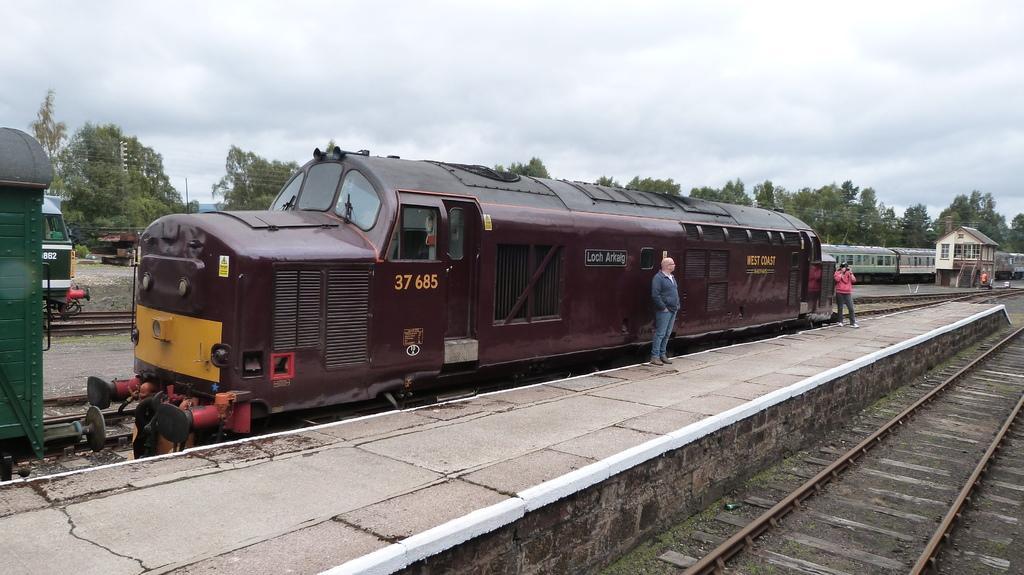Please provide a concise description of this image. In the foreground I can see trains on the track and two persons are standing on the platform. In the background I can see grass, trees, wires, light poles, hut and the sky. This image is taken may be during a day. 